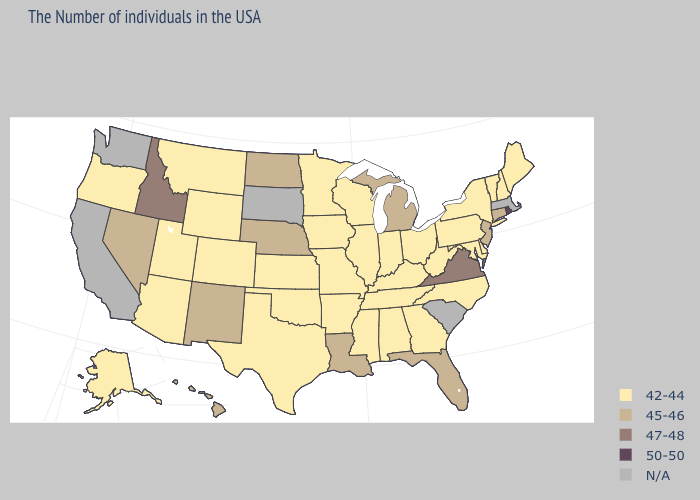What is the highest value in states that border Oregon?
Write a very short answer. 47-48. How many symbols are there in the legend?
Answer briefly. 5. Name the states that have a value in the range 47-48?
Quick response, please. Virginia, Idaho. What is the value of Oregon?
Quick response, please. 42-44. Which states have the highest value in the USA?
Short answer required. Rhode Island. Does Nebraska have the highest value in the MidWest?
Write a very short answer. Yes. Name the states that have a value in the range N/A?
Keep it brief. Massachusetts, South Carolina, South Dakota, California, Washington. Does Minnesota have the lowest value in the MidWest?
Concise answer only. Yes. Name the states that have a value in the range 45-46?
Be succinct. Connecticut, New Jersey, Florida, Michigan, Louisiana, Nebraska, North Dakota, New Mexico, Nevada, Hawaii. What is the highest value in the USA?
Answer briefly. 50-50. Among the states that border Texas , does Oklahoma have the lowest value?
Write a very short answer. Yes. Does Pennsylvania have the highest value in the USA?
Keep it brief. No. What is the value of Maine?
Short answer required. 42-44. 